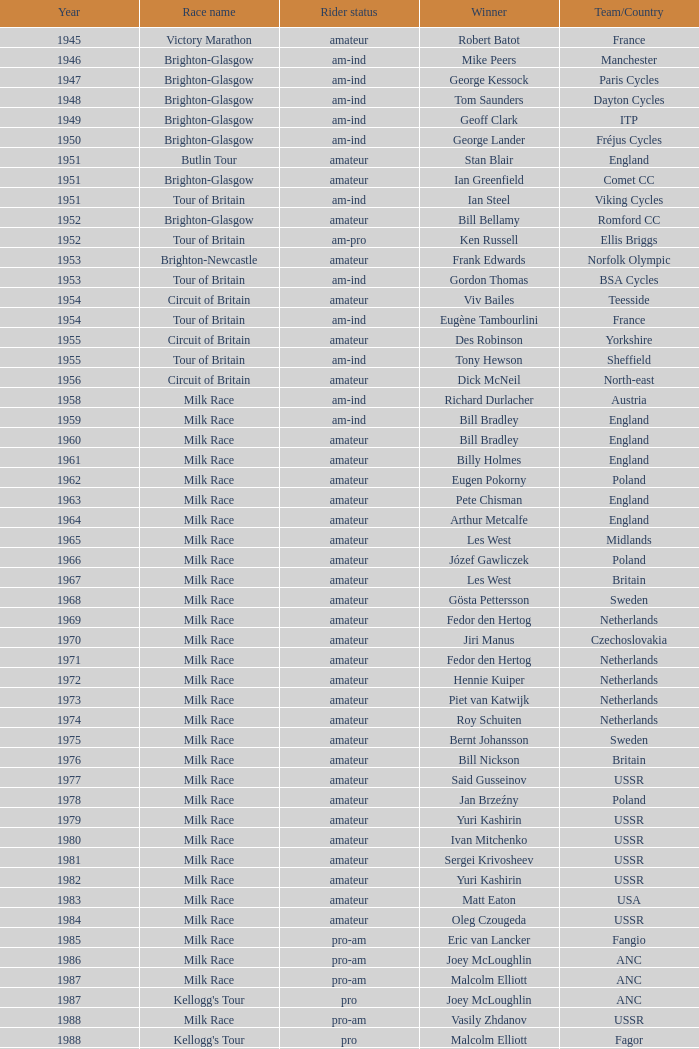What is the rider status for the 1971 netherlands team? Amateur. 